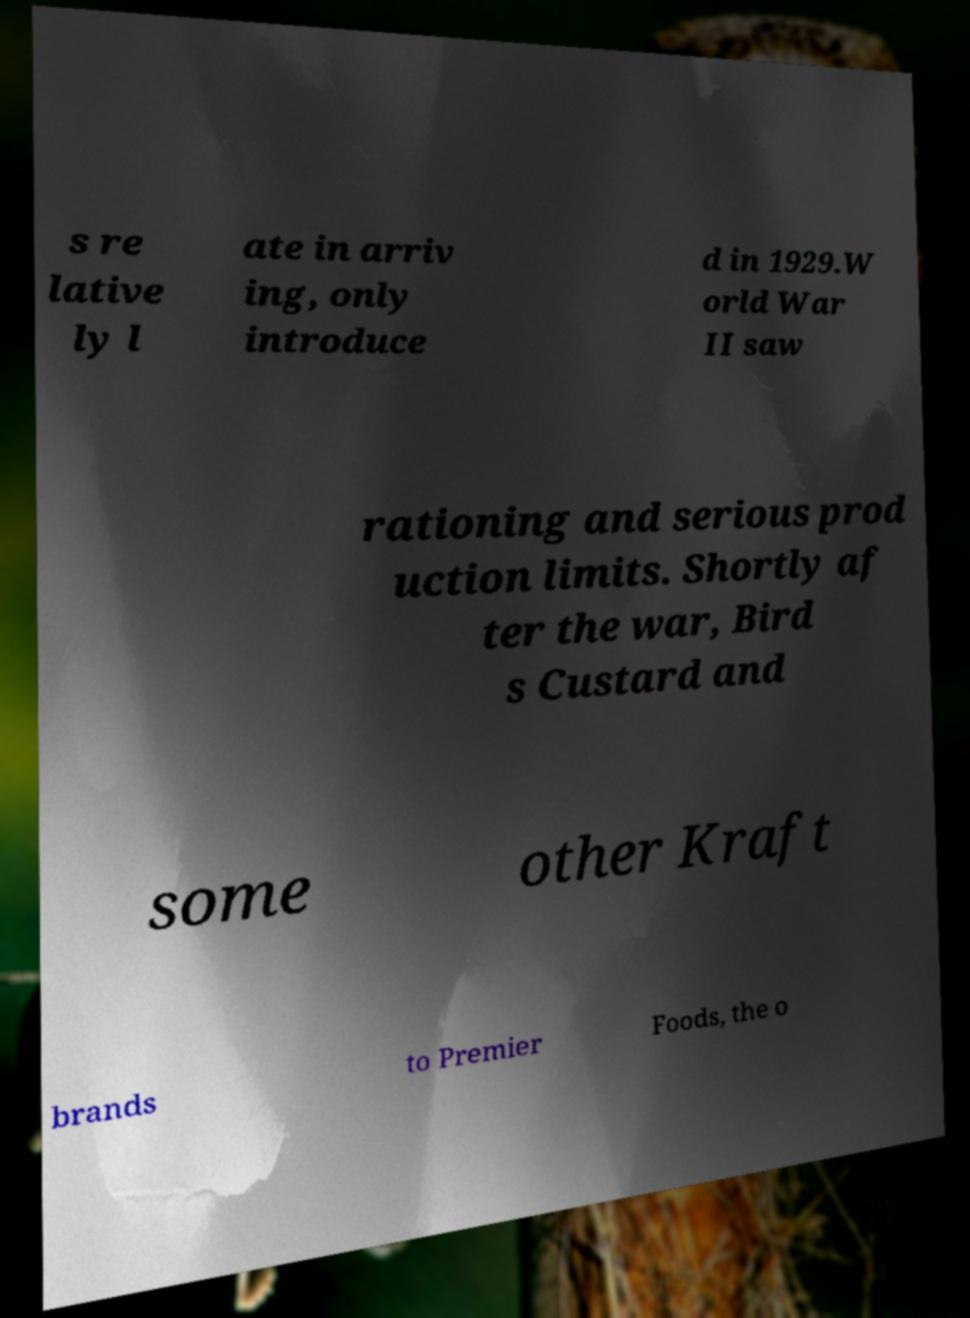For documentation purposes, I need the text within this image transcribed. Could you provide that? s re lative ly l ate in arriv ing, only introduce d in 1929.W orld War II saw rationing and serious prod uction limits. Shortly af ter the war, Bird s Custard and some other Kraft brands to Premier Foods, the o 